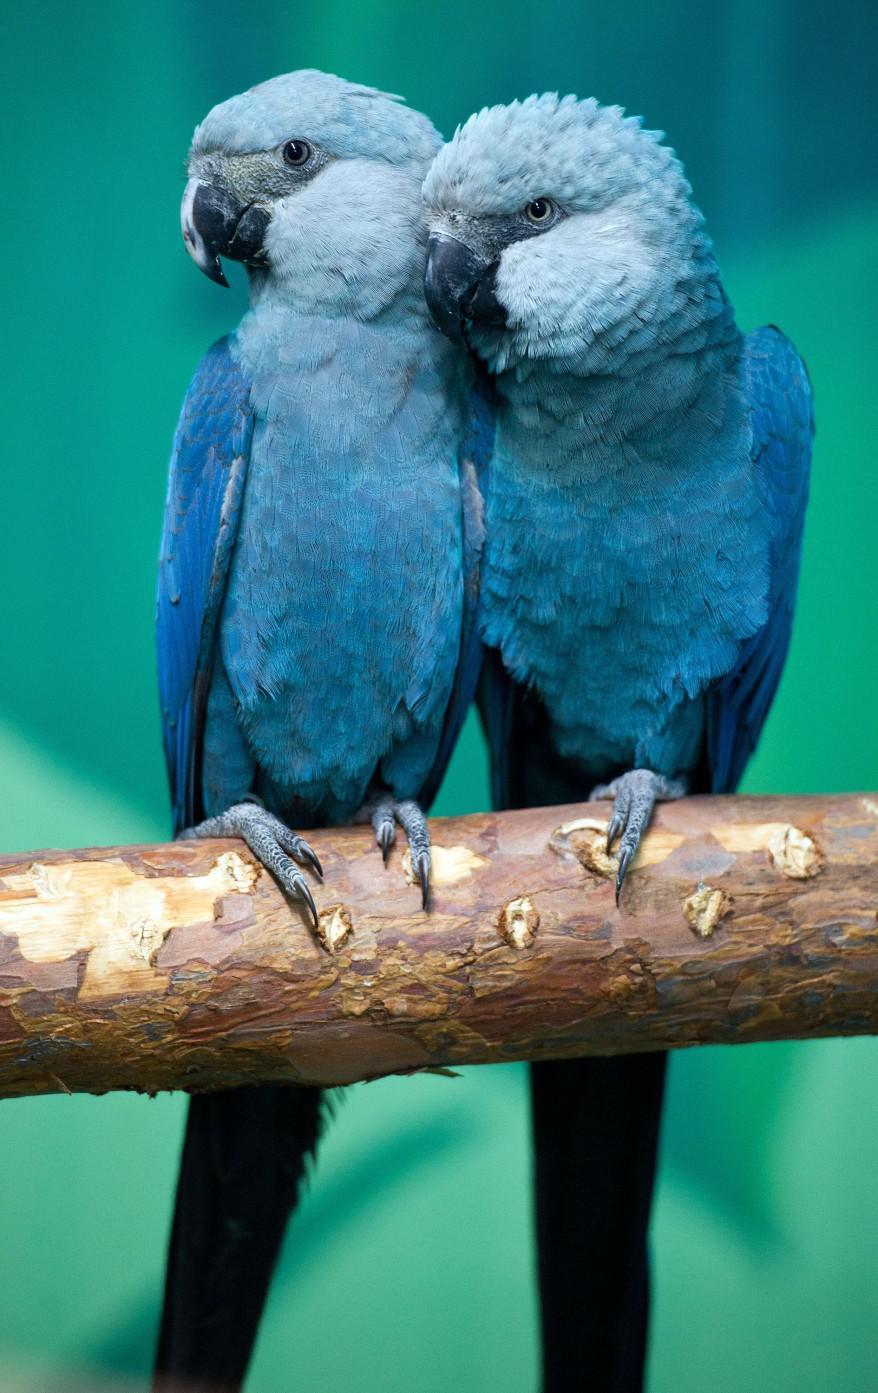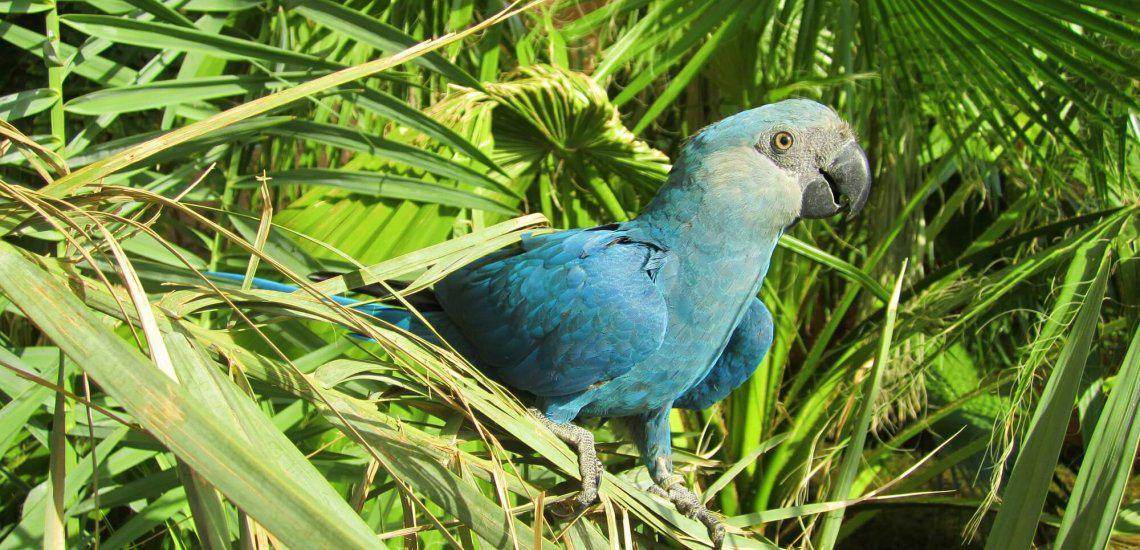The first image is the image on the left, the second image is the image on the right. Examine the images to the left and right. Is the description "All blue parrots have white faces with black eyes and beak that is black and white." accurate? Answer yes or no. No. The first image is the image on the left, the second image is the image on the right. Assess this claim about the two images: "There are two birds in the left image and one bird in the right image.". Correct or not? Answer yes or no. Yes. 